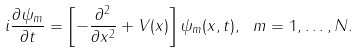<formula> <loc_0><loc_0><loc_500><loc_500>i \frac { \partial \psi _ { m } } { \partial t } = \left [ - \frac { \partial ^ { 2 } } { \partial x ^ { 2 } } + V ( x ) \right ] \psi _ { m } ( x , t ) , \ m = 1 , \dots , N .</formula> 